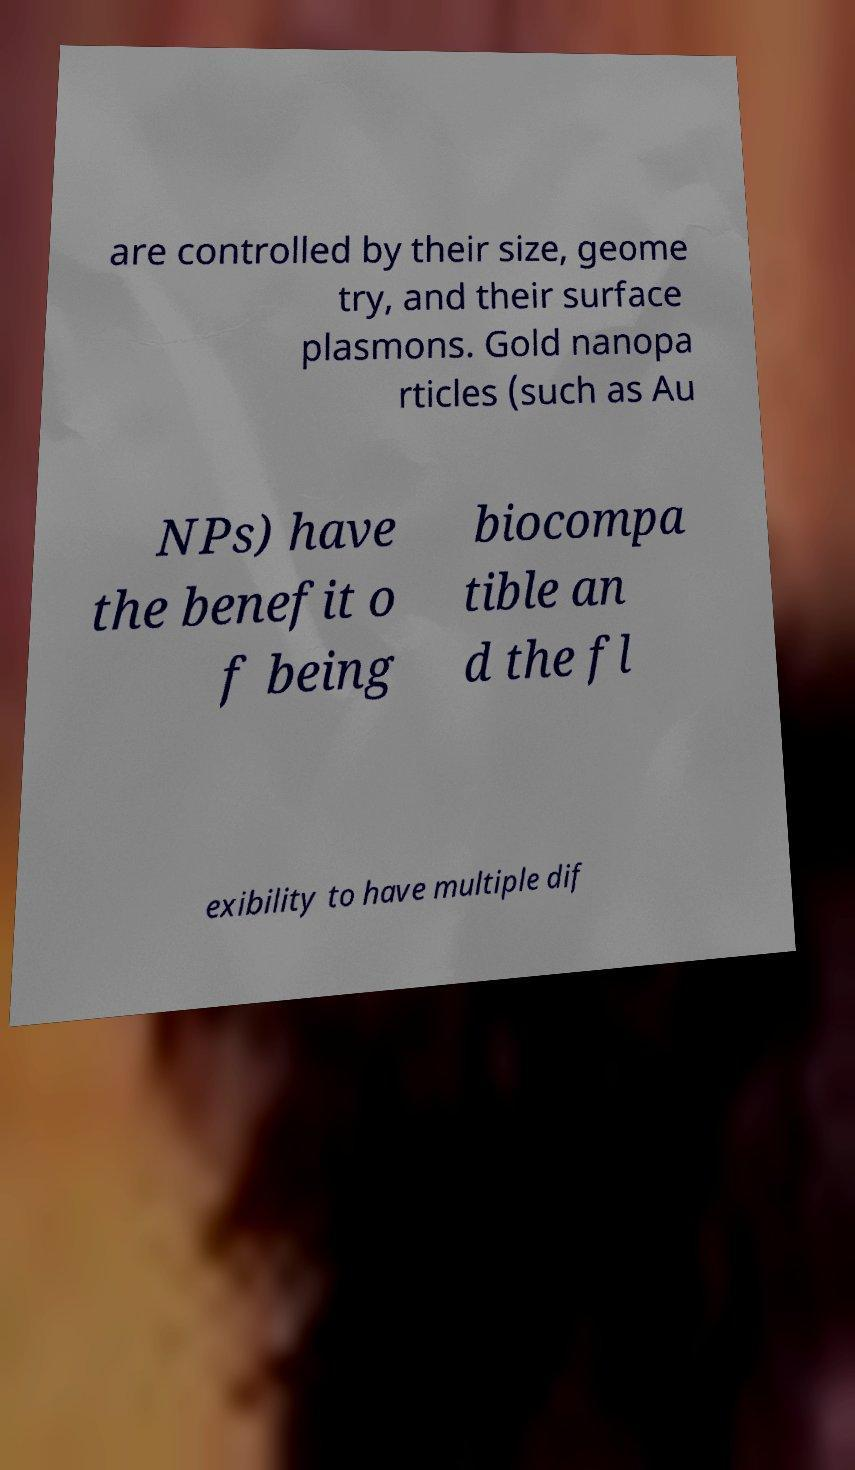Could you assist in decoding the text presented in this image and type it out clearly? are controlled by their size, geome try, and their surface plasmons. Gold nanopa rticles (such as Au NPs) have the benefit o f being biocompa tible an d the fl exibility to have multiple dif 